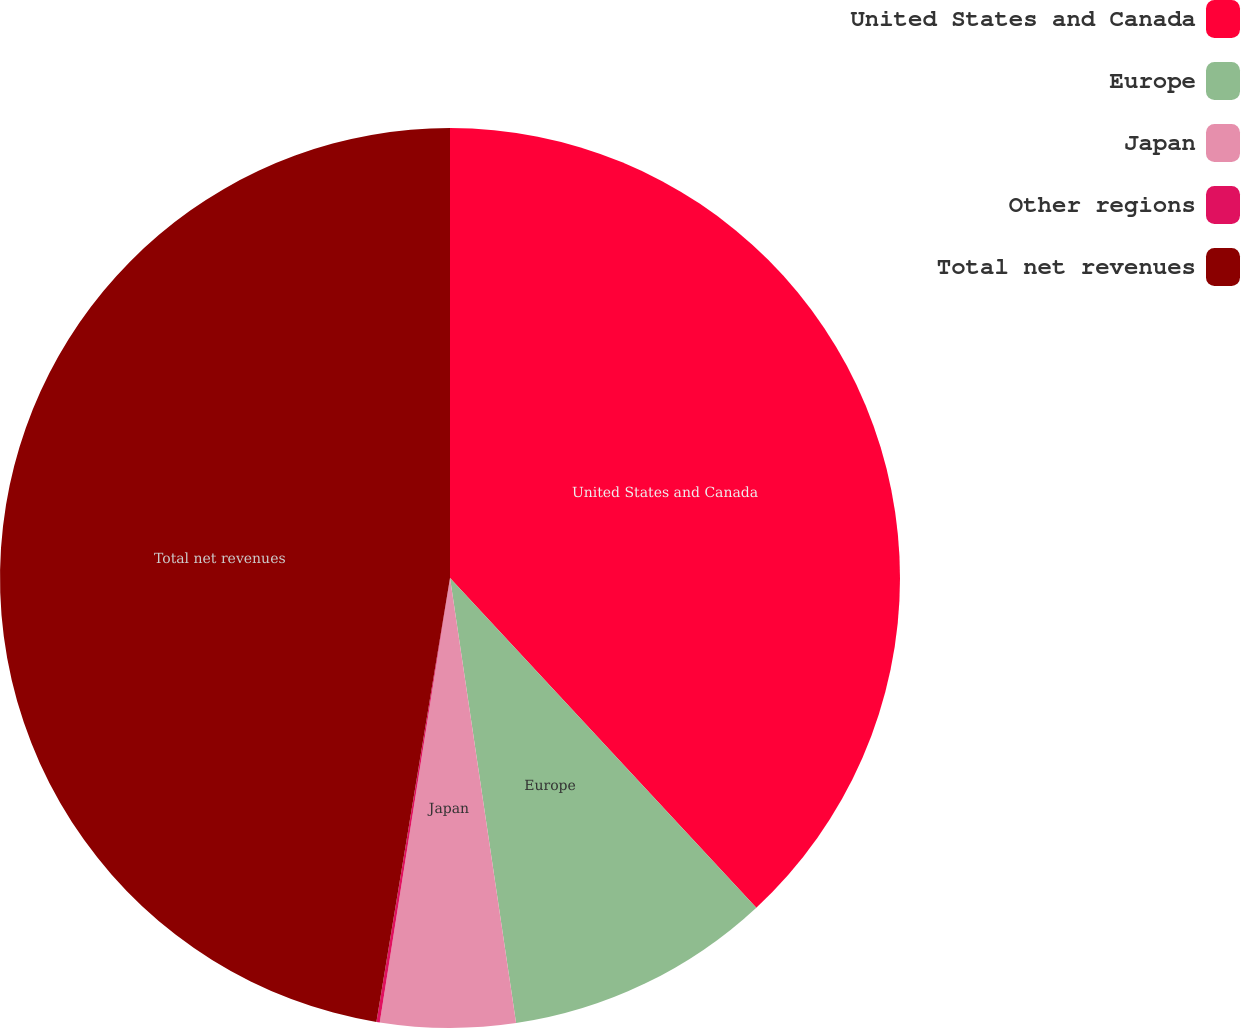Convert chart. <chart><loc_0><loc_0><loc_500><loc_500><pie_chart><fcel>United States and Canada<fcel>Europe<fcel>Japan<fcel>Other regions<fcel>Total net revenues<nl><fcel>38.08%<fcel>9.57%<fcel>4.84%<fcel>0.12%<fcel>47.38%<nl></chart> 